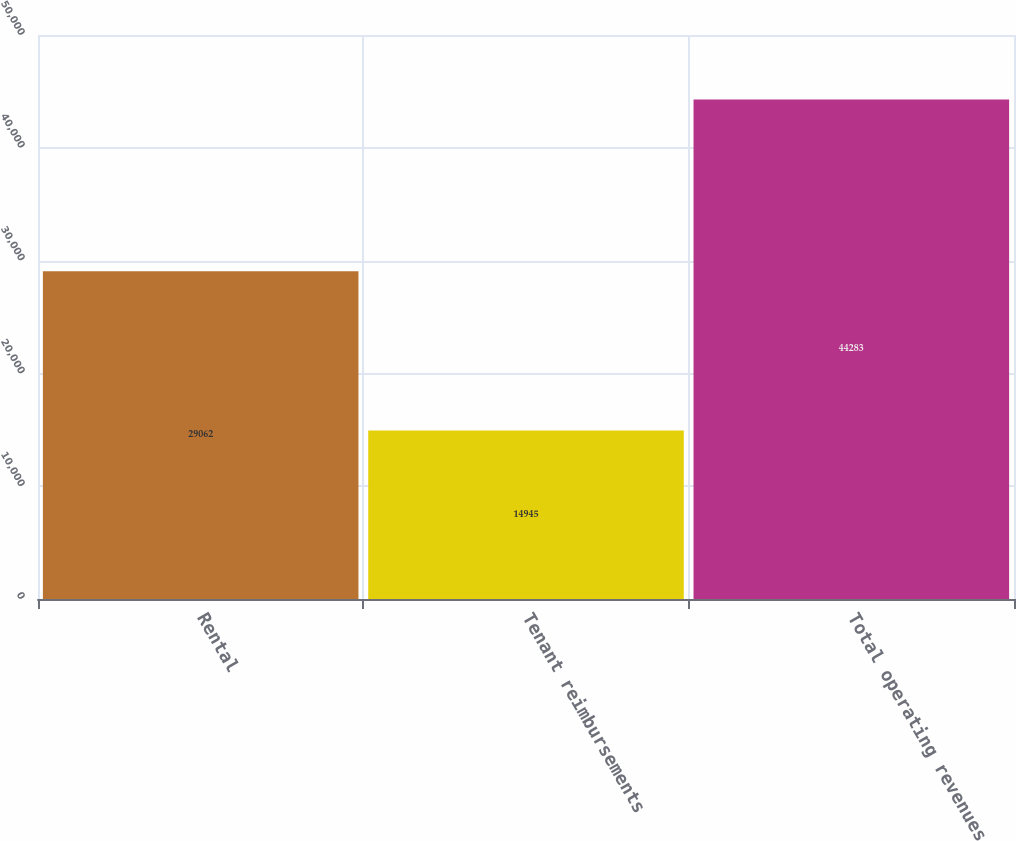Convert chart. <chart><loc_0><loc_0><loc_500><loc_500><bar_chart><fcel>Rental<fcel>Tenant reimbursements<fcel>Total operating revenues<nl><fcel>29062<fcel>14945<fcel>44283<nl></chart> 